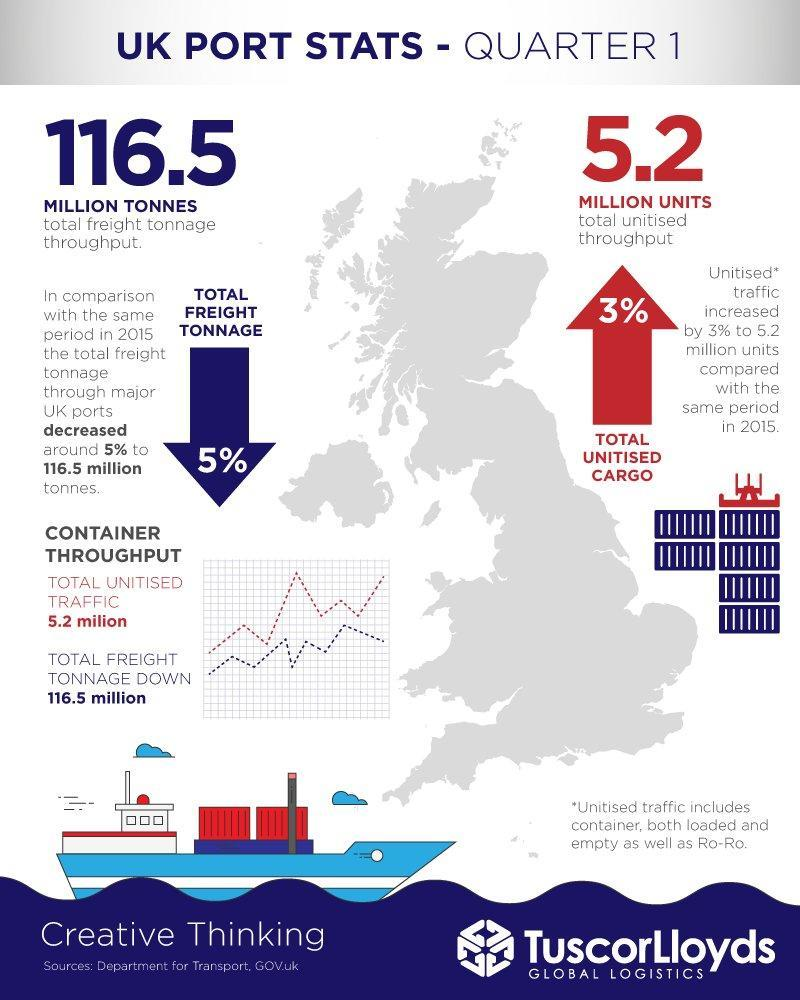What is the total throughput in tonnes?
Answer the question with a short phrase. 116.5 million tonnes What is the total throughput in units? 5.2 million 